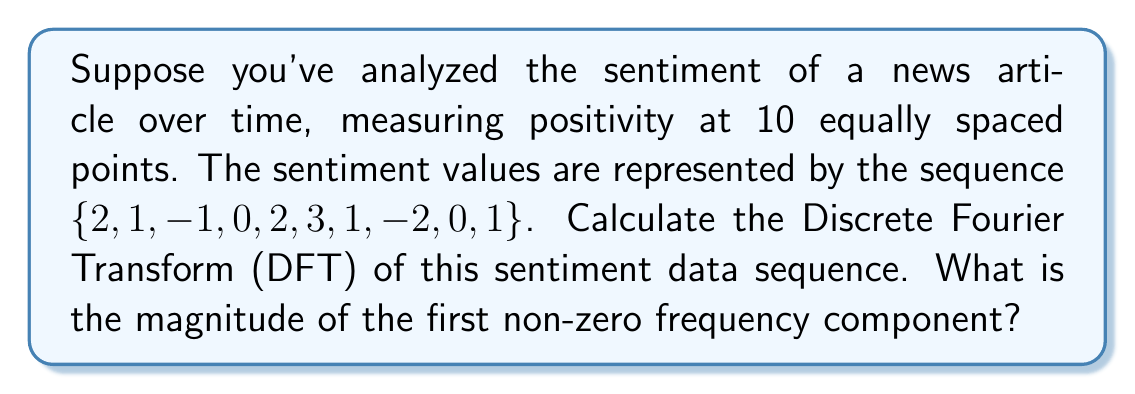Provide a solution to this math problem. To solve this problem, we'll follow these steps:

1) The Discrete Fourier Transform (DFT) of a sequence $x[n]$ of length N is given by:

   $$X[k] = \sum_{n=0}^{N-1} x[n] e^{-i2\pi kn/N}$$

   where $k = 0, 1, ..., N-1$

2) In our case, N = 10 and the sequence is $x[n] = \{2, 1, -1, 0, 2, 3, 1, -2, 0, 1\}$

3) We need to calculate $X[k]$ for $k = 1$ (first non-zero frequency):

   $$X[1] = \sum_{n=0}^{9} x[n] e^{-i2\pi n/10}$$

4) Let's calculate this sum:

   $X[1] = 2e^{0} + 1e^{-i2\pi/10} + (-1)e^{-i4\pi/10} + 0e^{-i6\pi/10} + 2e^{-i8\pi/10} + 3e^{-i\pi} + 1e^{-i12\pi/10} + (-2)e^{-i14\pi/10} + 0e^{-i16\pi/10} + 1e^{-i18\pi/10}$

5) Simplify using Euler's formula $(e^{ix} = \cos x + i\sin x)$:

   $X[1] = 2 + (0.809 - 0.588i) + (-0.309 - 0.951i) + 0 + (-0.809 - 0.588i) + (-3) + (-0.309 + 0.951i) + (1.618 - 1.176i) + 0 + (0.809 + 0.588i)$

6) Sum the real and imaginary parts:

   $X[1] = 0.809 - 1.764i$

7) The magnitude of a complex number $a + bi$ is given by $\sqrt{a^2 + b^2}$:

   $|X[1]| = \sqrt{0.809^2 + (-1.764)^2} = \sqrt{0.654 + 3.112} = \sqrt{3.766} \approx 1.941$
Answer: $1.941$ 